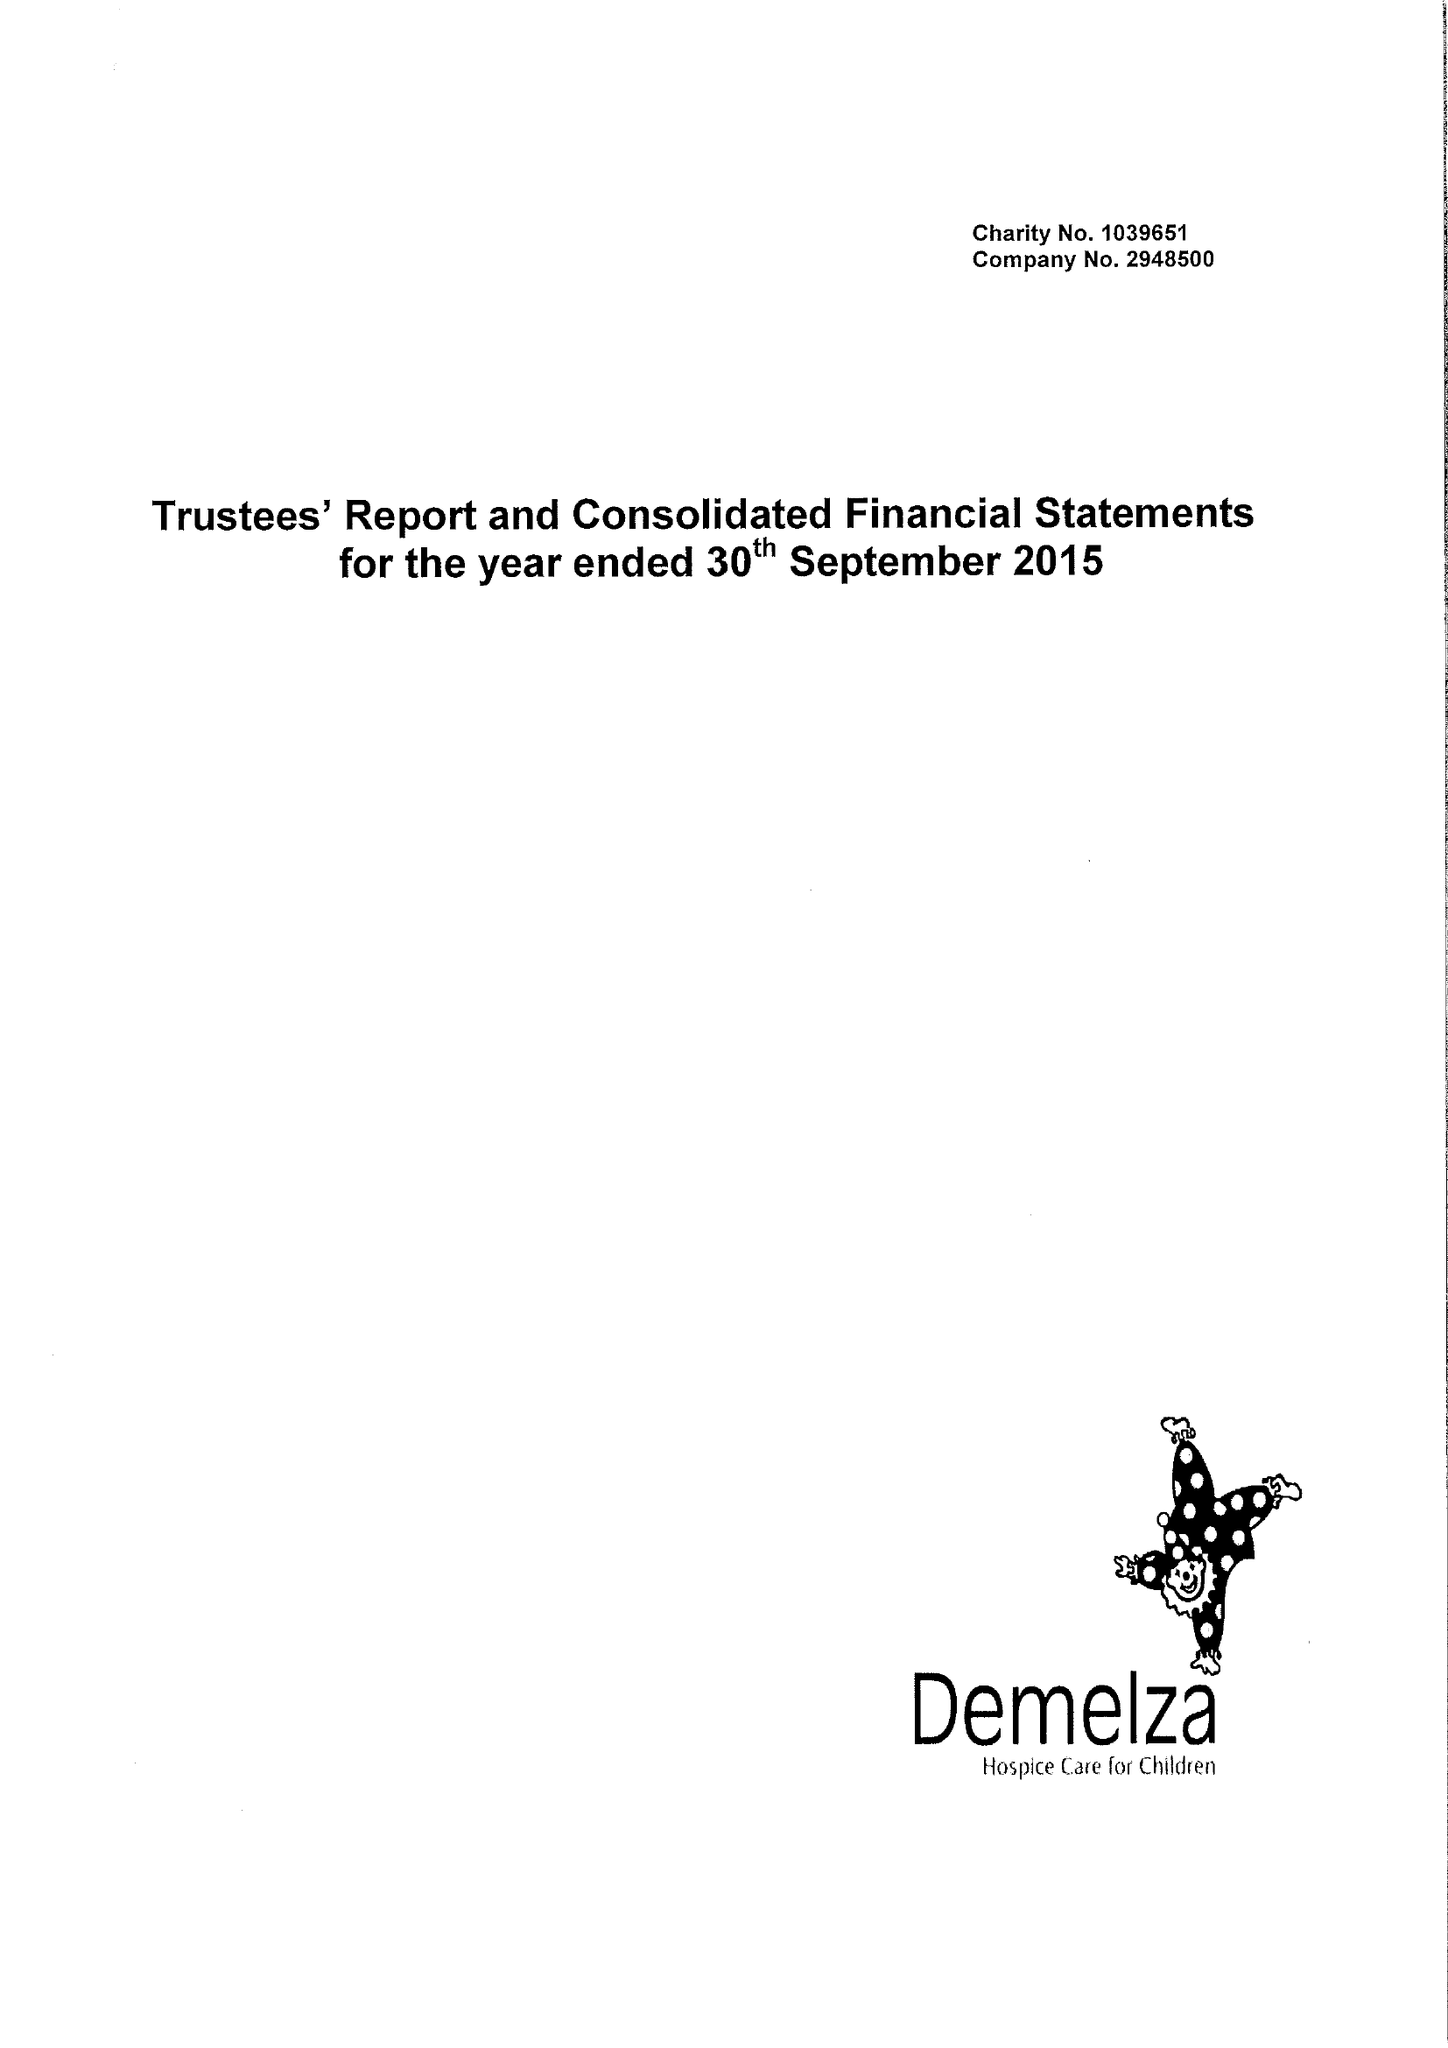What is the value for the charity_name?
Answer the question using a single word or phrase. Demelza House Childrens Hospice 